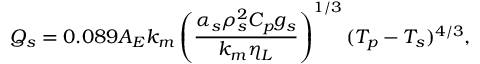Convert formula to latex. <formula><loc_0><loc_0><loc_500><loc_500>Q _ { s } = 0 . 0 8 9 A _ { E } k _ { m } \left ( \frac { \alpha _ { s } \rho _ { s } ^ { 2 } C _ { p } g _ { s } } { k _ { m } \eta _ { L } } \right ) ^ { 1 / 3 } ( T _ { p } - T _ { s } ) ^ { 4 / 3 } ,</formula> 